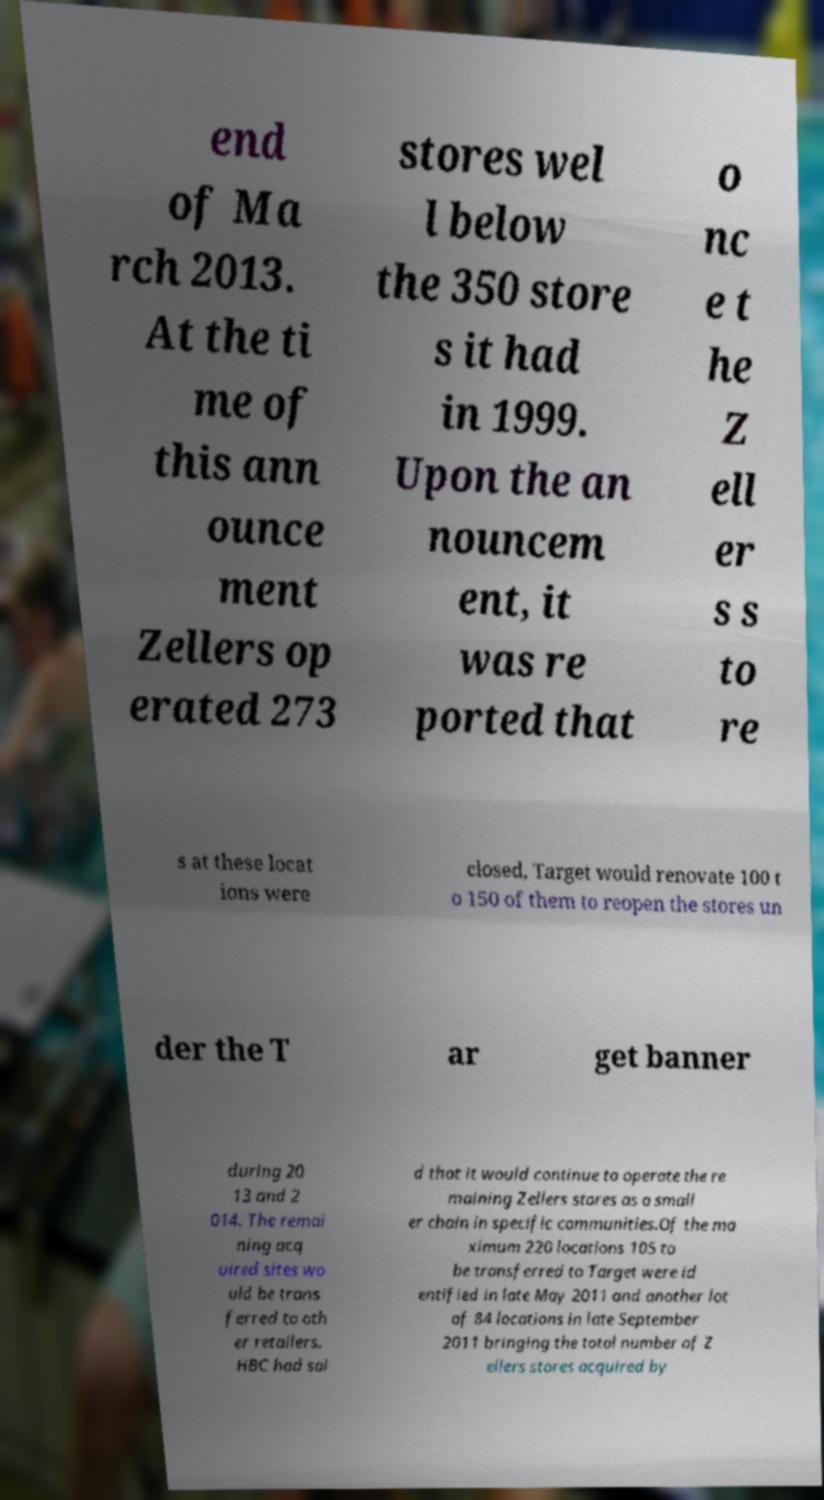Can you accurately transcribe the text from the provided image for me? end of Ma rch 2013. At the ti me of this ann ounce ment Zellers op erated 273 stores wel l below the 350 store s it had in 1999. Upon the an nouncem ent, it was re ported that o nc e t he Z ell er s s to re s at these locat ions were closed, Target would renovate 100 t o 150 of them to reopen the stores un der the T ar get banner during 20 13 and 2 014. The remai ning acq uired sites wo uld be trans ferred to oth er retailers. HBC had sai d that it would continue to operate the re maining Zellers stores as a small er chain in specific communities.Of the ma ximum 220 locations 105 to be transferred to Target were id entified in late May 2011 and another lot of 84 locations in late September 2011 bringing the total number of Z ellers stores acquired by 